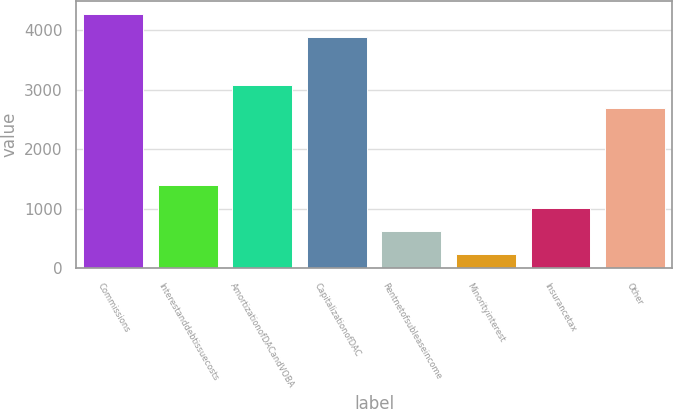Convert chart. <chart><loc_0><loc_0><loc_500><loc_500><bar_chart><fcel>Commissions<fcel>Interestanddebtissuecosts<fcel>AmortizationofDACandVOBA<fcel>CapitalizationofDAC<fcel>Rentnetofsubleaseincome<fcel>Minorityinterest<fcel>Insurancetax<fcel>Other<nl><fcel>4279.4<fcel>1402.2<fcel>3081.4<fcel>3892<fcel>627.4<fcel>240<fcel>1014.8<fcel>2694<nl></chart> 